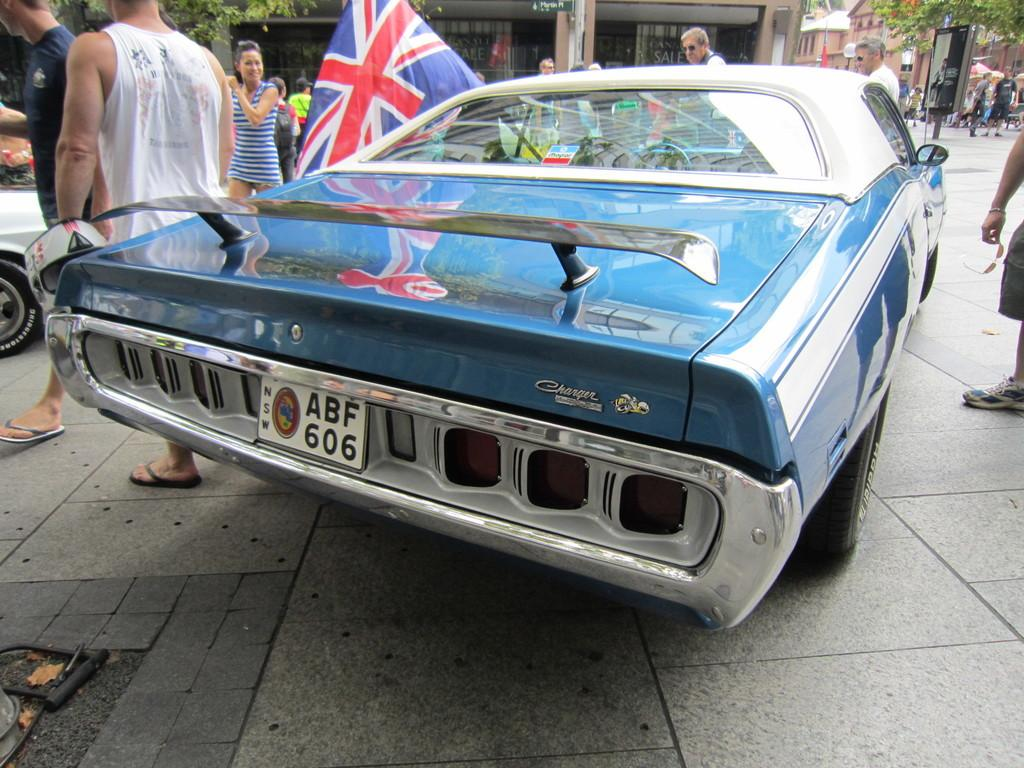<image>
Relay a brief, clear account of the picture shown. a license plate that has the letters ABF on it 